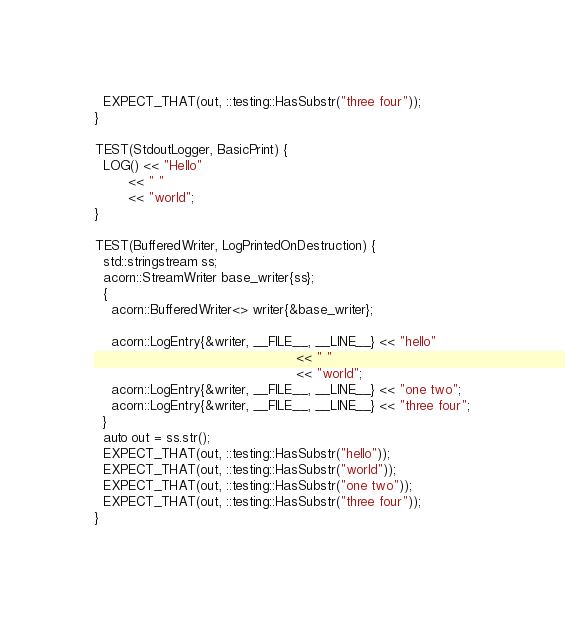Convert code to text. <code><loc_0><loc_0><loc_500><loc_500><_C++_>  EXPECT_THAT(out, ::testing::HasSubstr("three four"));
}

TEST(StdoutLogger, BasicPrint) {
  LOG() << "Hello"
        << " "
        << "world";
}

TEST(BufferedWriter, LogPrintedOnDestruction) {
  std::stringstream ss;
  acorn::StreamWriter base_writer{ss};
  {
    acorn::BufferedWriter<> writer{&base_writer};

    acorn::LogEntry{&writer, __FILE__, __LINE__} << "hello"
                                                 << " "
                                                 << "world";
    acorn::LogEntry{&writer, __FILE__, __LINE__} << "one two";
    acorn::LogEntry{&writer, __FILE__, __LINE__} << "three four";
  }
  auto out = ss.str();
  EXPECT_THAT(out, ::testing::HasSubstr("hello"));
  EXPECT_THAT(out, ::testing::HasSubstr("world"));
  EXPECT_THAT(out, ::testing::HasSubstr("one two"));
  EXPECT_THAT(out, ::testing::HasSubstr("three four"));
}
</code> 